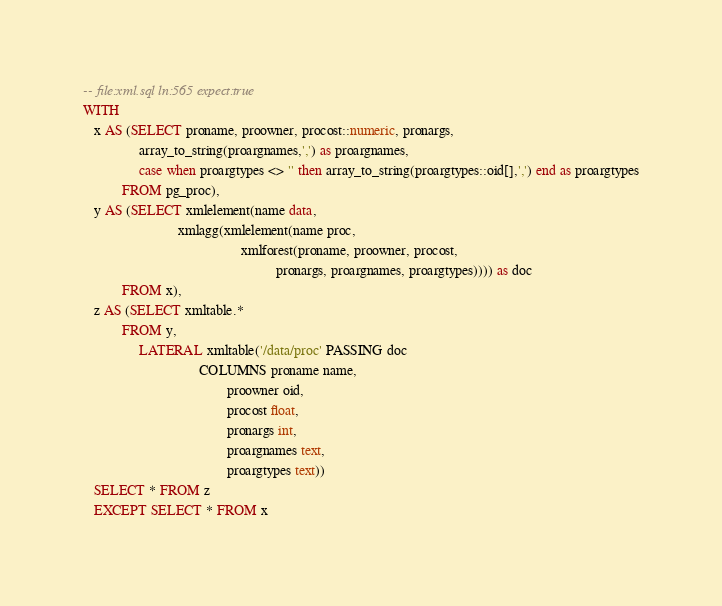Convert code to text. <code><loc_0><loc_0><loc_500><loc_500><_SQL_>-- file:xml.sql ln:565 expect:true
WITH
   x AS (SELECT proname, proowner, procost::numeric, pronargs,
                array_to_string(proargnames,',') as proargnames,
                case when proargtypes <> '' then array_to_string(proargtypes::oid[],',') end as proargtypes
           FROM pg_proc),
   y AS (SELECT xmlelement(name data,
                           xmlagg(xmlelement(name proc,
                                             xmlforest(proname, proowner, procost,
                                                       pronargs, proargnames, proargtypes)))) as doc
           FROM x),
   z AS (SELECT xmltable.*
           FROM y,
                LATERAL xmltable('/data/proc' PASSING doc
                                 COLUMNS proname name,
                                         proowner oid,
                                         procost float,
                                         pronargs int,
                                         proargnames text,
                                         proargtypes text))
   SELECT * FROM z
   EXCEPT SELECT * FROM x
</code> 